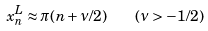<formula> <loc_0><loc_0><loc_500><loc_500>x _ { n } ^ { L } \approx \pi ( n + \nu / 2 ) \quad ( \nu > - 1 / 2 )</formula> 